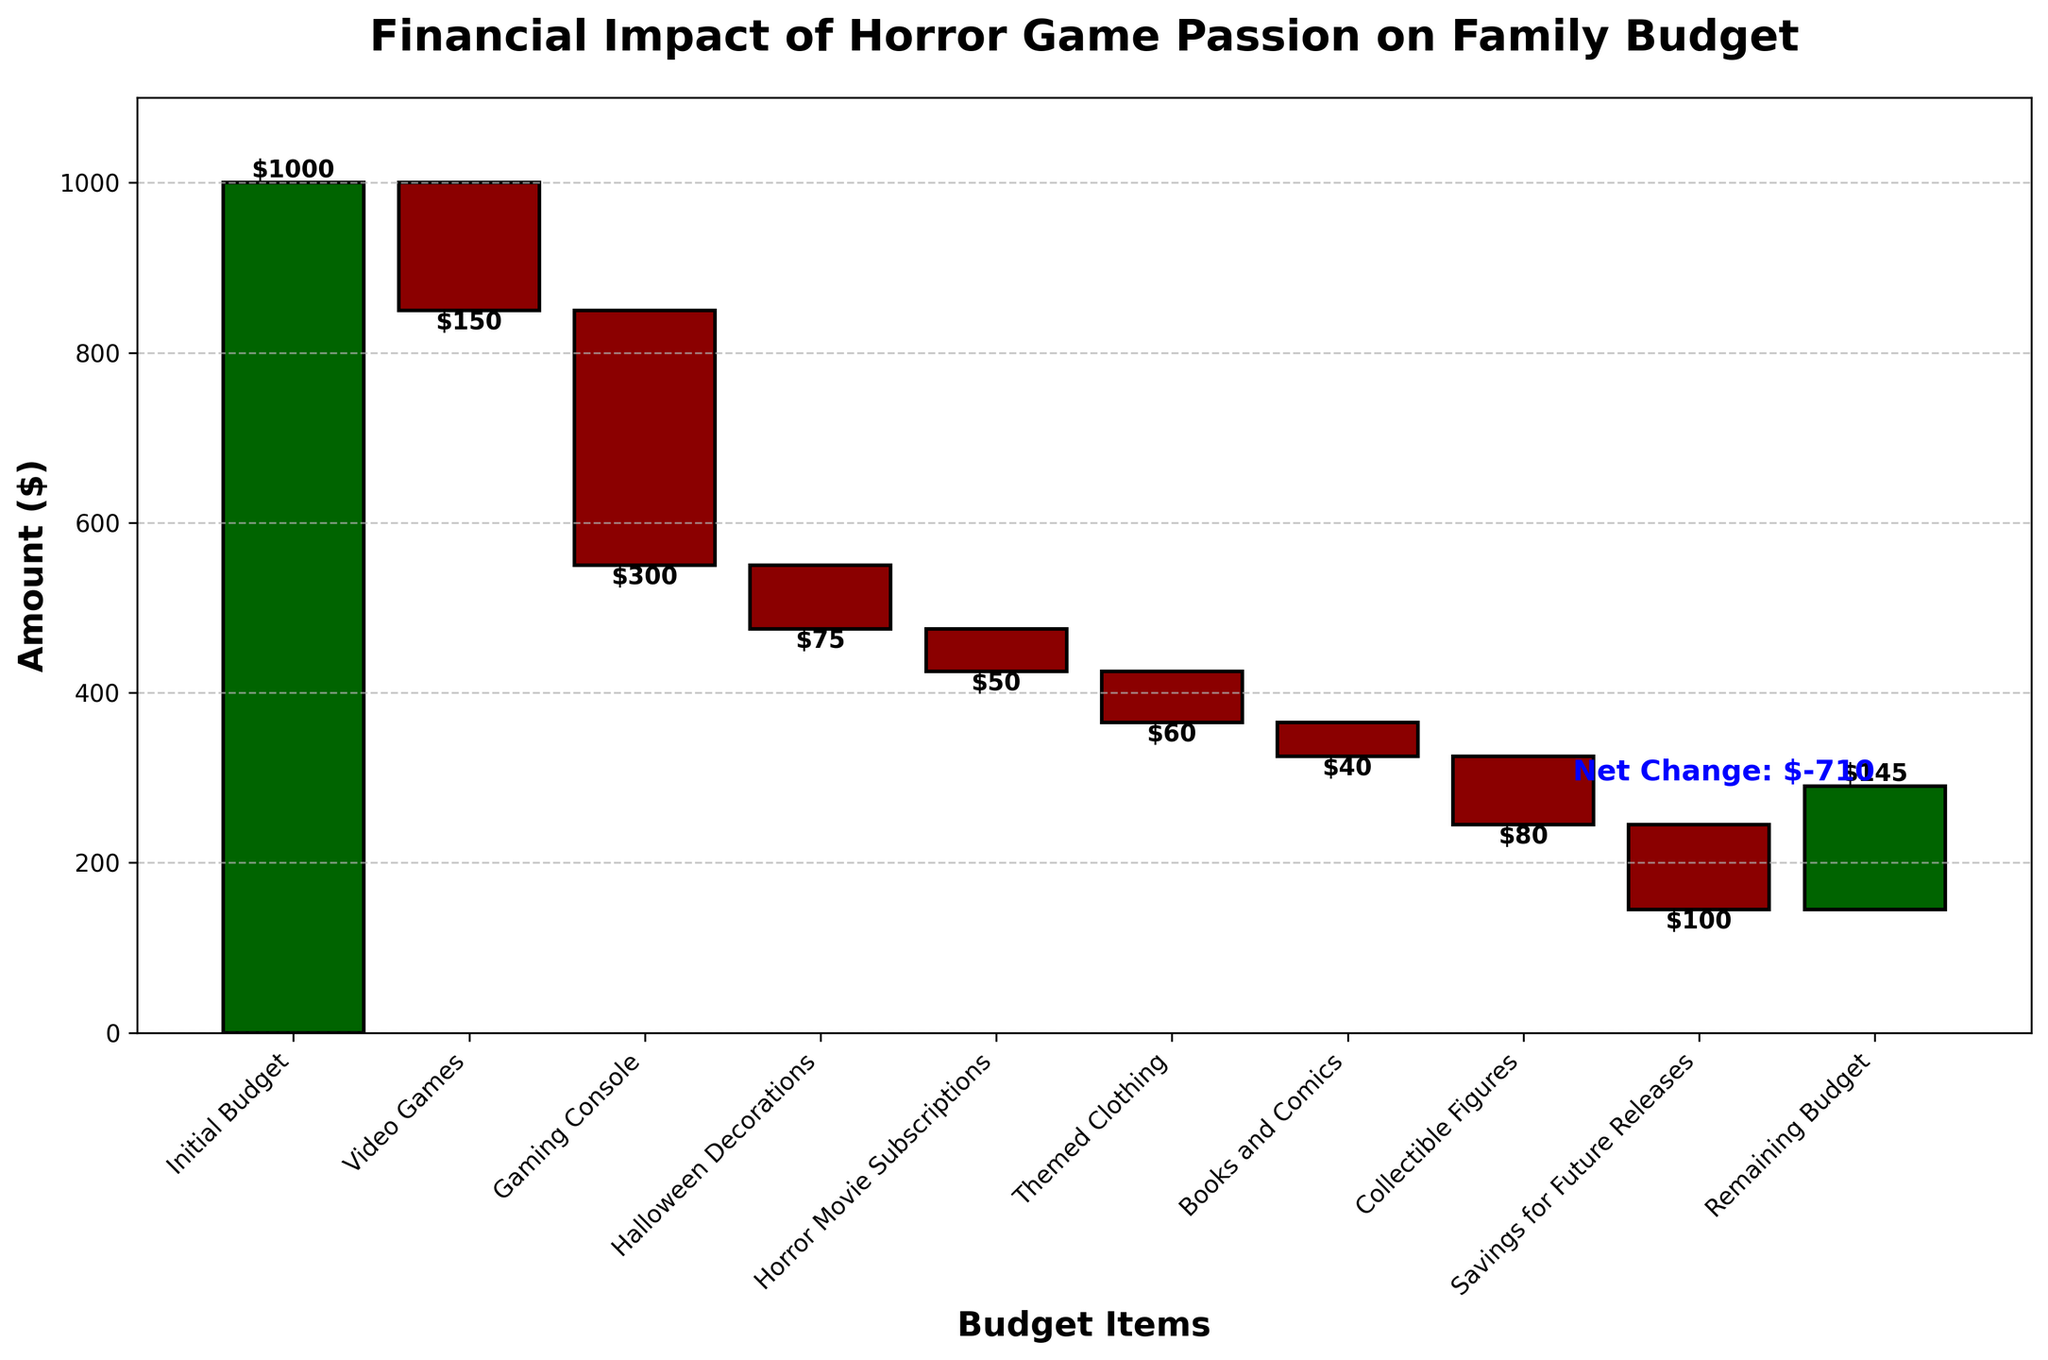What is the initial budget set for the family? The initial budget is shown at the top of the chart labeled "Initial Budget" with a value of $1000
Answer: $1000 Which category represents the highest spending? Observing the lengths of the negative bars, "Gaming Console" has the longest bar with a value of -$300, indicating the highest spending in this category
Answer: Gaming Console How much is spent on horror movie subscriptions? In the chart, "Horror Movie Subscriptions" is labeled with a negative value of -$50
Answer: $50 What is the remaining budget after all the expenses? The last bar labeled "Remaining Budget" shows the final amount of $145
Answer: $145 What is the net change in the budget from the initial to the remaining amount? The net change is calculated as the difference between the initial budget ($1000) and the remaining budget ($145), so $1000 - $145 = $855
Answer: $855 How much does the family save for future releases of games? The bar labeled "Savings for Future Releases" shows a value of -$100
Answer: $100 Which expenses are smaller than $100? Observing the bars with negative values, the following categories have expenses smaller than $100: "Halloween Decorations" (-$75), "Horror Movie Subscriptions" (-$50), "Themed Clothing" (-$60), "Books and Comics" (-$40), and "Savings for Future Releases" (-$100)
Answer: Halloween Decorations, Horror Movie Subscriptions, Themed Clothing, Books and Comics, Savings for Future Releases What is the total expenditure on both the gaming console and video games? Adding the amounts from "Gaming Console" (-$300) and "Video Games" (-$150), so -$300 + -$150 = -$450
Answer: $450 How does the expense on collectible figures compare to that on horror movie subscriptions? The expense on collectible figures (-$80) is compared to horror movie subscriptions (-$50). -$80 is greater than -$50, indicating the expense on collectible figures is higher
Answer: Collectible Figures What percentage of the initial budget is left as the remaining budget? The remaining budget ($145) is divided by the initial budget ($1000) then multiplied by 100 to find the percentage: ($145 / $1000) * 100 = 14.5%
Answer: 14.5% 